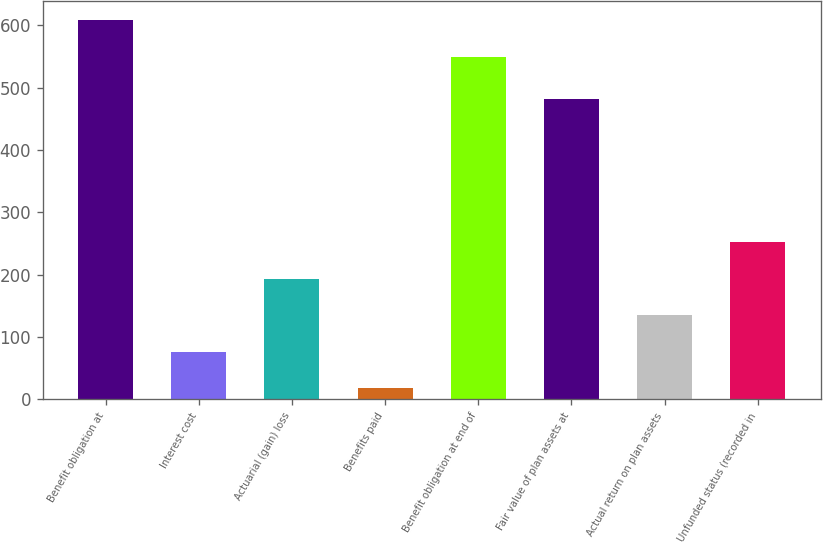Convert chart. <chart><loc_0><loc_0><loc_500><loc_500><bar_chart><fcel>Benefit obligation at<fcel>Interest cost<fcel>Actuarial (gain) loss<fcel>Benefits paid<fcel>Benefit obligation at end of<fcel>Fair value of plan assets at<fcel>Actual return on plan assets<fcel>Unfunded status (recorded in<nl><fcel>608.5<fcel>76.5<fcel>193.5<fcel>18<fcel>550<fcel>482.5<fcel>135<fcel>252<nl></chart> 